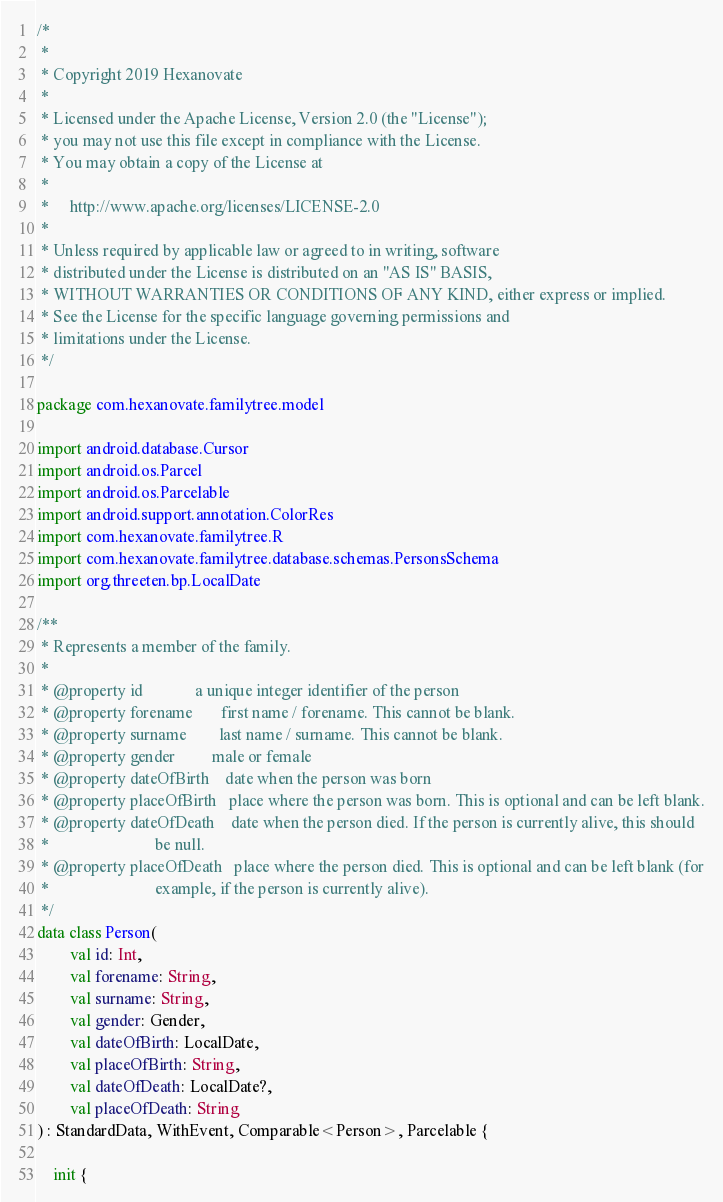Convert code to text. <code><loc_0><loc_0><loc_500><loc_500><_Kotlin_>/*
 *
 * Copyright 2019 Hexanovate
 *
 * Licensed under the Apache License, Version 2.0 (the "License");
 * you may not use this file except in compliance with the License.
 * You may obtain a copy of the License at
 *
 *     http://www.apache.org/licenses/LICENSE-2.0
 *
 * Unless required by applicable law or agreed to in writing, software
 * distributed under the License is distributed on an "AS IS" BASIS,
 * WITHOUT WARRANTIES OR CONDITIONS OF ANY KIND, either express or implied.
 * See the License for the specific language governing permissions and
 * limitations under the License.
 */

package com.hexanovate.familytree.model

import android.database.Cursor
import android.os.Parcel
import android.os.Parcelable
import android.support.annotation.ColorRes
import com.hexanovate.familytree.R
import com.hexanovate.familytree.database.schemas.PersonsSchema
import org.threeten.bp.LocalDate

/**
 * Represents a member of the family.
 *
 * @property id             a unique integer identifier of the person
 * @property forename       first name / forename. This cannot be blank.
 * @property surname        last name / surname. This cannot be blank.
 * @property gender         male or female
 * @property dateOfBirth    date when the person was born
 * @property placeOfBirth   place where the person was born. This is optional and can be left blank.
 * @property dateOfDeath    date when the person died. If the person is currently alive, this should
 *                          be null.
 * @property placeOfDeath   place where the person died. This is optional and can be left blank (for
 *                          example, if the person is currently alive).
 */
data class Person(
        val id: Int,
        val forename: String,
        val surname: String,
        val gender: Gender,
        val dateOfBirth: LocalDate,
        val placeOfBirth: String,
        val dateOfDeath: LocalDate?,
        val placeOfDeath: String
) : StandardData, WithEvent, Comparable<Person>, Parcelable {

    init {</code> 